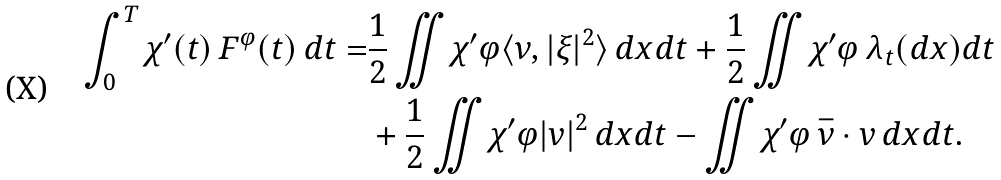<formula> <loc_0><loc_0><loc_500><loc_500>\int _ { 0 } ^ { T } \chi ^ { \prime } ( t ) \, F ^ { \varphi } ( t ) \, d t = & \frac { 1 } { 2 } \iint \chi ^ { \prime } \varphi \langle \nu , | \xi | ^ { 2 } \rangle \, d x d t + \frac { 1 } { 2 } \iint \chi ^ { \prime } \varphi \, \lambda _ { t } ( d x ) d t \\ & + \frac { 1 } { 2 } \iint \chi ^ { \prime } \varphi | v | ^ { 2 } \, d x d t - \iint \chi ^ { \prime } \varphi \, \bar { \nu } \cdot v \, d x d t .</formula> 